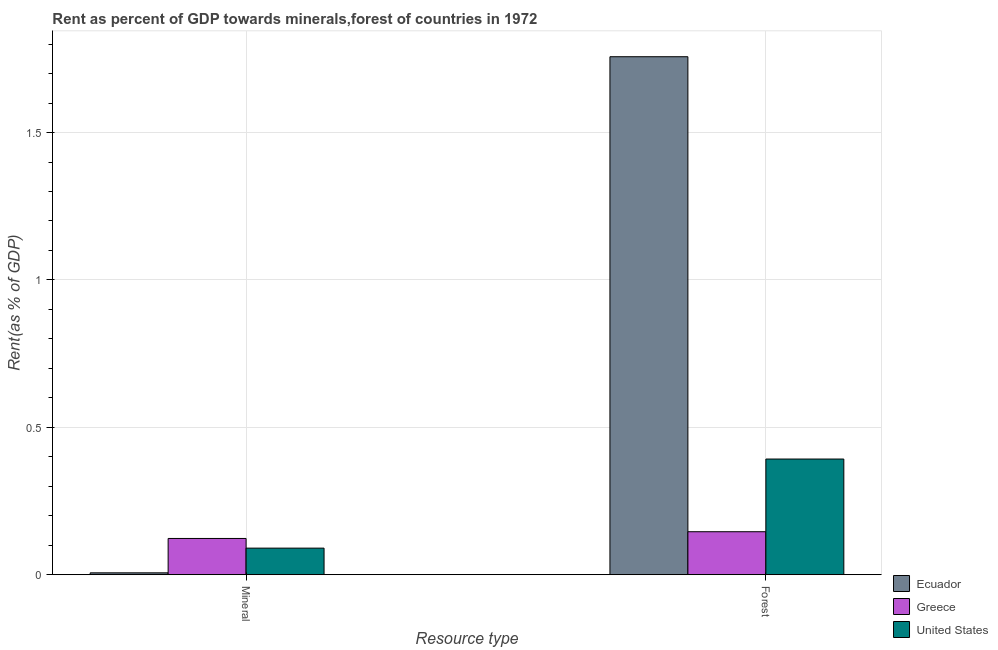How many groups of bars are there?
Provide a succinct answer. 2. Are the number of bars per tick equal to the number of legend labels?
Your response must be concise. Yes. Are the number of bars on each tick of the X-axis equal?
Offer a very short reply. Yes. How many bars are there on the 2nd tick from the left?
Your answer should be compact. 3. What is the label of the 2nd group of bars from the left?
Your answer should be very brief. Forest. What is the forest rent in United States?
Ensure brevity in your answer.  0.39. Across all countries, what is the maximum mineral rent?
Offer a very short reply. 0.12. Across all countries, what is the minimum mineral rent?
Your answer should be very brief. 0.01. In which country was the forest rent maximum?
Make the answer very short. Ecuador. What is the total mineral rent in the graph?
Offer a very short reply. 0.22. What is the difference between the mineral rent in United States and that in Ecuador?
Your answer should be compact. 0.08. What is the difference between the mineral rent in Ecuador and the forest rent in United States?
Make the answer very short. -0.39. What is the average mineral rent per country?
Provide a short and direct response. 0.07. What is the difference between the mineral rent and forest rent in Greece?
Ensure brevity in your answer.  -0.02. In how many countries, is the forest rent greater than 0.8 %?
Keep it short and to the point. 1. What is the ratio of the forest rent in Greece to that in Ecuador?
Make the answer very short. 0.08. What does the 2nd bar from the left in Mineral represents?
Offer a very short reply. Greece. What does the 3rd bar from the right in Forest represents?
Offer a very short reply. Ecuador. Are all the bars in the graph horizontal?
Your answer should be very brief. No. How many countries are there in the graph?
Give a very brief answer. 3. Are the values on the major ticks of Y-axis written in scientific E-notation?
Your answer should be compact. No. Does the graph contain any zero values?
Your response must be concise. No. How many legend labels are there?
Your answer should be very brief. 3. What is the title of the graph?
Your answer should be compact. Rent as percent of GDP towards minerals,forest of countries in 1972. What is the label or title of the X-axis?
Make the answer very short. Resource type. What is the label or title of the Y-axis?
Your answer should be compact. Rent(as % of GDP). What is the Rent(as % of GDP) in Ecuador in Mineral?
Keep it short and to the point. 0.01. What is the Rent(as % of GDP) of Greece in Mineral?
Keep it short and to the point. 0.12. What is the Rent(as % of GDP) in United States in Mineral?
Your answer should be very brief. 0.09. What is the Rent(as % of GDP) in Ecuador in Forest?
Provide a succinct answer. 1.76. What is the Rent(as % of GDP) of Greece in Forest?
Offer a terse response. 0.15. What is the Rent(as % of GDP) of United States in Forest?
Provide a short and direct response. 0.39. Across all Resource type, what is the maximum Rent(as % of GDP) of Ecuador?
Your answer should be compact. 1.76. Across all Resource type, what is the maximum Rent(as % of GDP) of Greece?
Give a very brief answer. 0.15. Across all Resource type, what is the maximum Rent(as % of GDP) of United States?
Keep it short and to the point. 0.39. Across all Resource type, what is the minimum Rent(as % of GDP) in Ecuador?
Offer a terse response. 0.01. Across all Resource type, what is the minimum Rent(as % of GDP) in Greece?
Keep it short and to the point. 0.12. Across all Resource type, what is the minimum Rent(as % of GDP) of United States?
Give a very brief answer. 0.09. What is the total Rent(as % of GDP) in Ecuador in the graph?
Provide a short and direct response. 1.76. What is the total Rent(as % of GDP) of Greece in the graph?
Offer a very short reply. 0.27. What is the total Rent(as % of GDP) of United States in the graph?
Provide a short and direct response. 0.48. What is the difference between the Rent(as % of GDP) in Ecuador in Mineral and that in Forest?
Offer a very short reply. -1.75. What is the difference between the Rent(as % of GDP) of Greece in Mineral and that in Forest?
Your response must be concise. -0.02. What is the difference between the Rent(as % of GDP) of United States in Mineral and that in Forest?
Offer a very short reply. -0.3. What is the difference between the Rent(as % of GDP) of Ecuador in Mineral and the Rent(as % of GDP) of Greece in Forest?
Your answer should be compact. -0.14. What is the difference between the Rent(as % of GDP) in Ecuador in Mineral and the Rent(as % of GDP) in United States in Forest?
Ensure brevity in your answer.  -0.39. What is the difference between the Rent(as % of GDP) of Greece in Mineral and the Rent(as % of GDP) of United States in Forest?
Keep it short and to the point. -0.27. What is the average Rent(as % of GDP) in Ecuador per Resource type?
Offer a very short reply. 0.88. What is the average Rent(as % of GDP) of Greece per Resource type?
Make the answer very short. 0.13. What is the average Rent(as % of GDP) of United States per Resource type?
Provide a succinct answer. 0.24. What is the difference between the Rent(as % of GDP) of Ecuador and Rent(as % of GDP) of Greece in Mineral?
Your answer should be very brief. -0.12. What is the difference between the Rent(as % of GDP) of Ecuador and Rent(as % of GDP) of United States in Mineral?
Provide a short and direct response. -0.08. What is the difference between the Rent(as % of GDP) in Greece and Rent(as % of GDP) in United States in Mineral?
Give a very brief answer. 0.03. What is the difference between the Rent(as % of GDP) of Ecuador and Rent(as % of GDP) of Greece in Forest?
Your answer should be compact. 1.61. What is the difference between the Rent(as % of GDP) in Ecuador and Rent(as % of GDP) in United States in Forest?
Your response must be concise. 1.36. What is the difference between the Rent(as % of GDP) in Greece and Rent(as % of GDP) in United States in Forest?
Keep it short and to the point. -0.25. What is the ratio of the Rent(as % of GDP) of Ecuador in Mineral to that in Forest?
Provide a short and direct response. 0. What is the ratio of the Rent(as % of GDP) of Greece in Mineral to that in Forest?
Offer a very short reply. 0.84. What is the ratio of the Rent(as % of GDP) of United States in Mineral to that in Forest?
Provide a short and direct response. 0.23. What is the difference between the highest and the second highest Rent(as % of GDP) of Ecuador?
Your response must be concise. 1.75. What is the difference between the highest and the second highest Rent(as % of GDP) of Greece?
Keep it short and to the point. 0.02. What is the difference between the highest and the second highest Rent(as % of GDP) in United States?
Provide a succinct answer. 0.3. What is the difference between the highest and the lowest Rent(as % of GDP) in Ecuador?
Ensure brevity in your answer.  1.75. What is the difference between the highest and the lowest Rent(as % of GDP) of Greece?
Make the answer very short. 0.02. What is the difference between the highest and the lowest Rent(as % of GDP) of United States?
Your response must be concise. 0.3. 